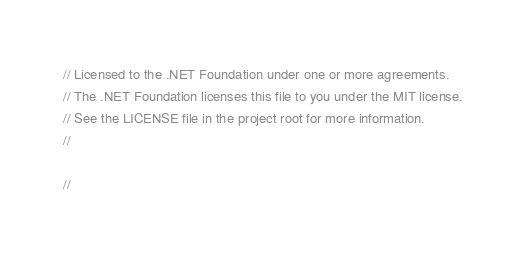<code> <loc_0><loc_0><loc_500><loc_500><_C++_>// Licensed to the .NET Foundation under one or more agreements.
// The .NET Foundation licenses this file to you under the MIT license.
// See the LICENSE file in the project root for more information.
//

//
</code> 